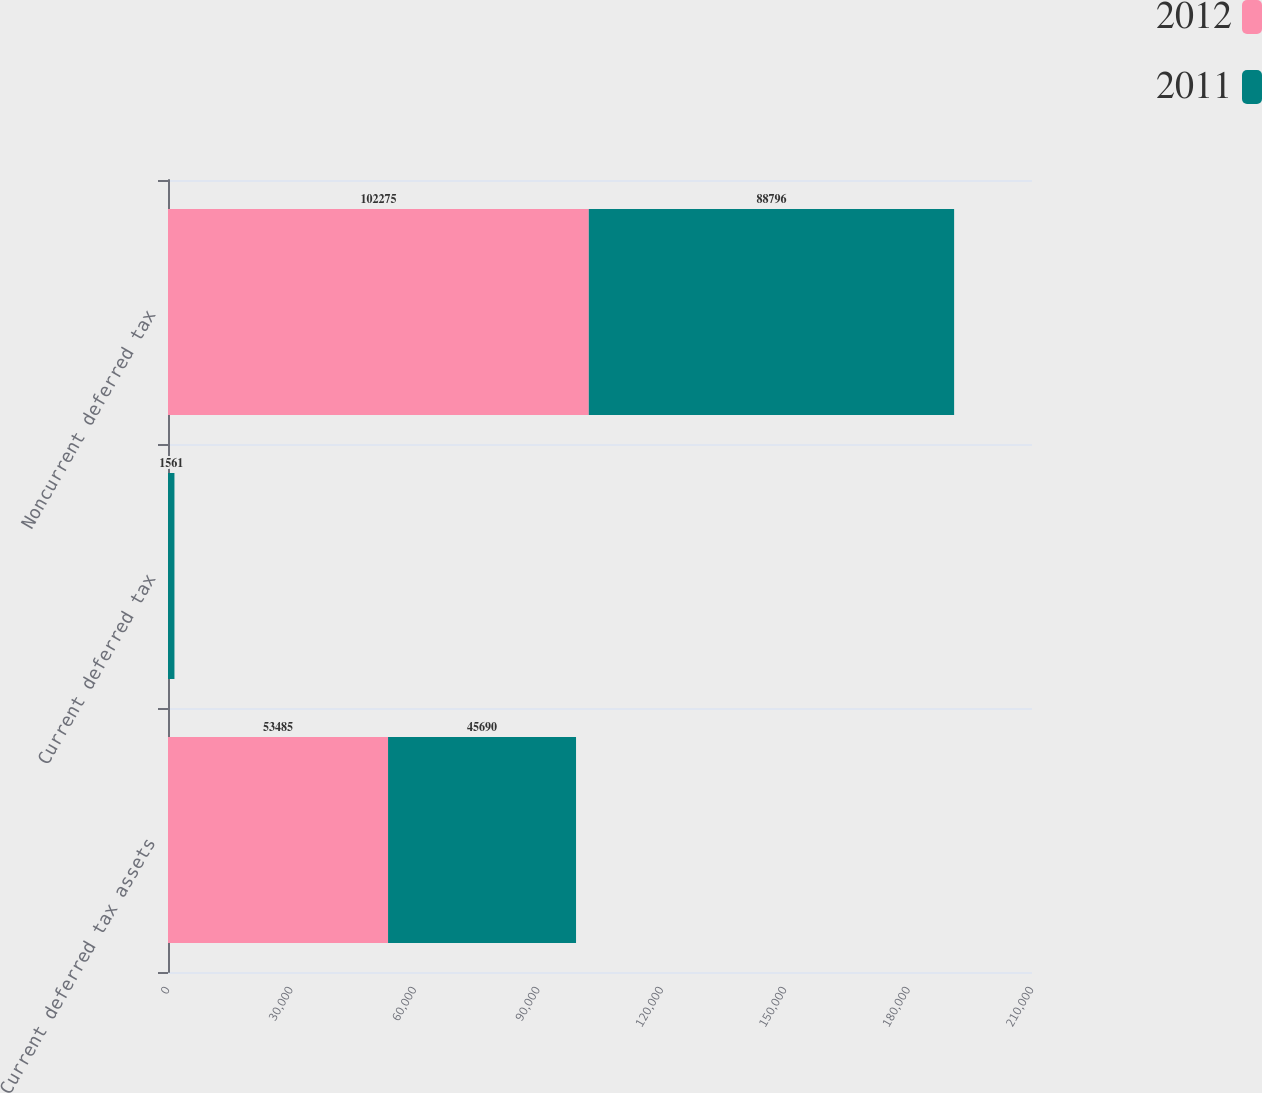Convert chart. <chart><loc_0><loc_0><loc_500><loc_500><stacked_bar_chart><ecel><fcel>Current deferred tax assets<fcel>Current deferred tax<fcel>Noncurrent deferred tax<nl><fcel>2012<fcel>53485<fcel>5<fcel>102275<nl><fcel>2011<fcel>45690<fcel>1561<fcel>88796<nl></chart> 